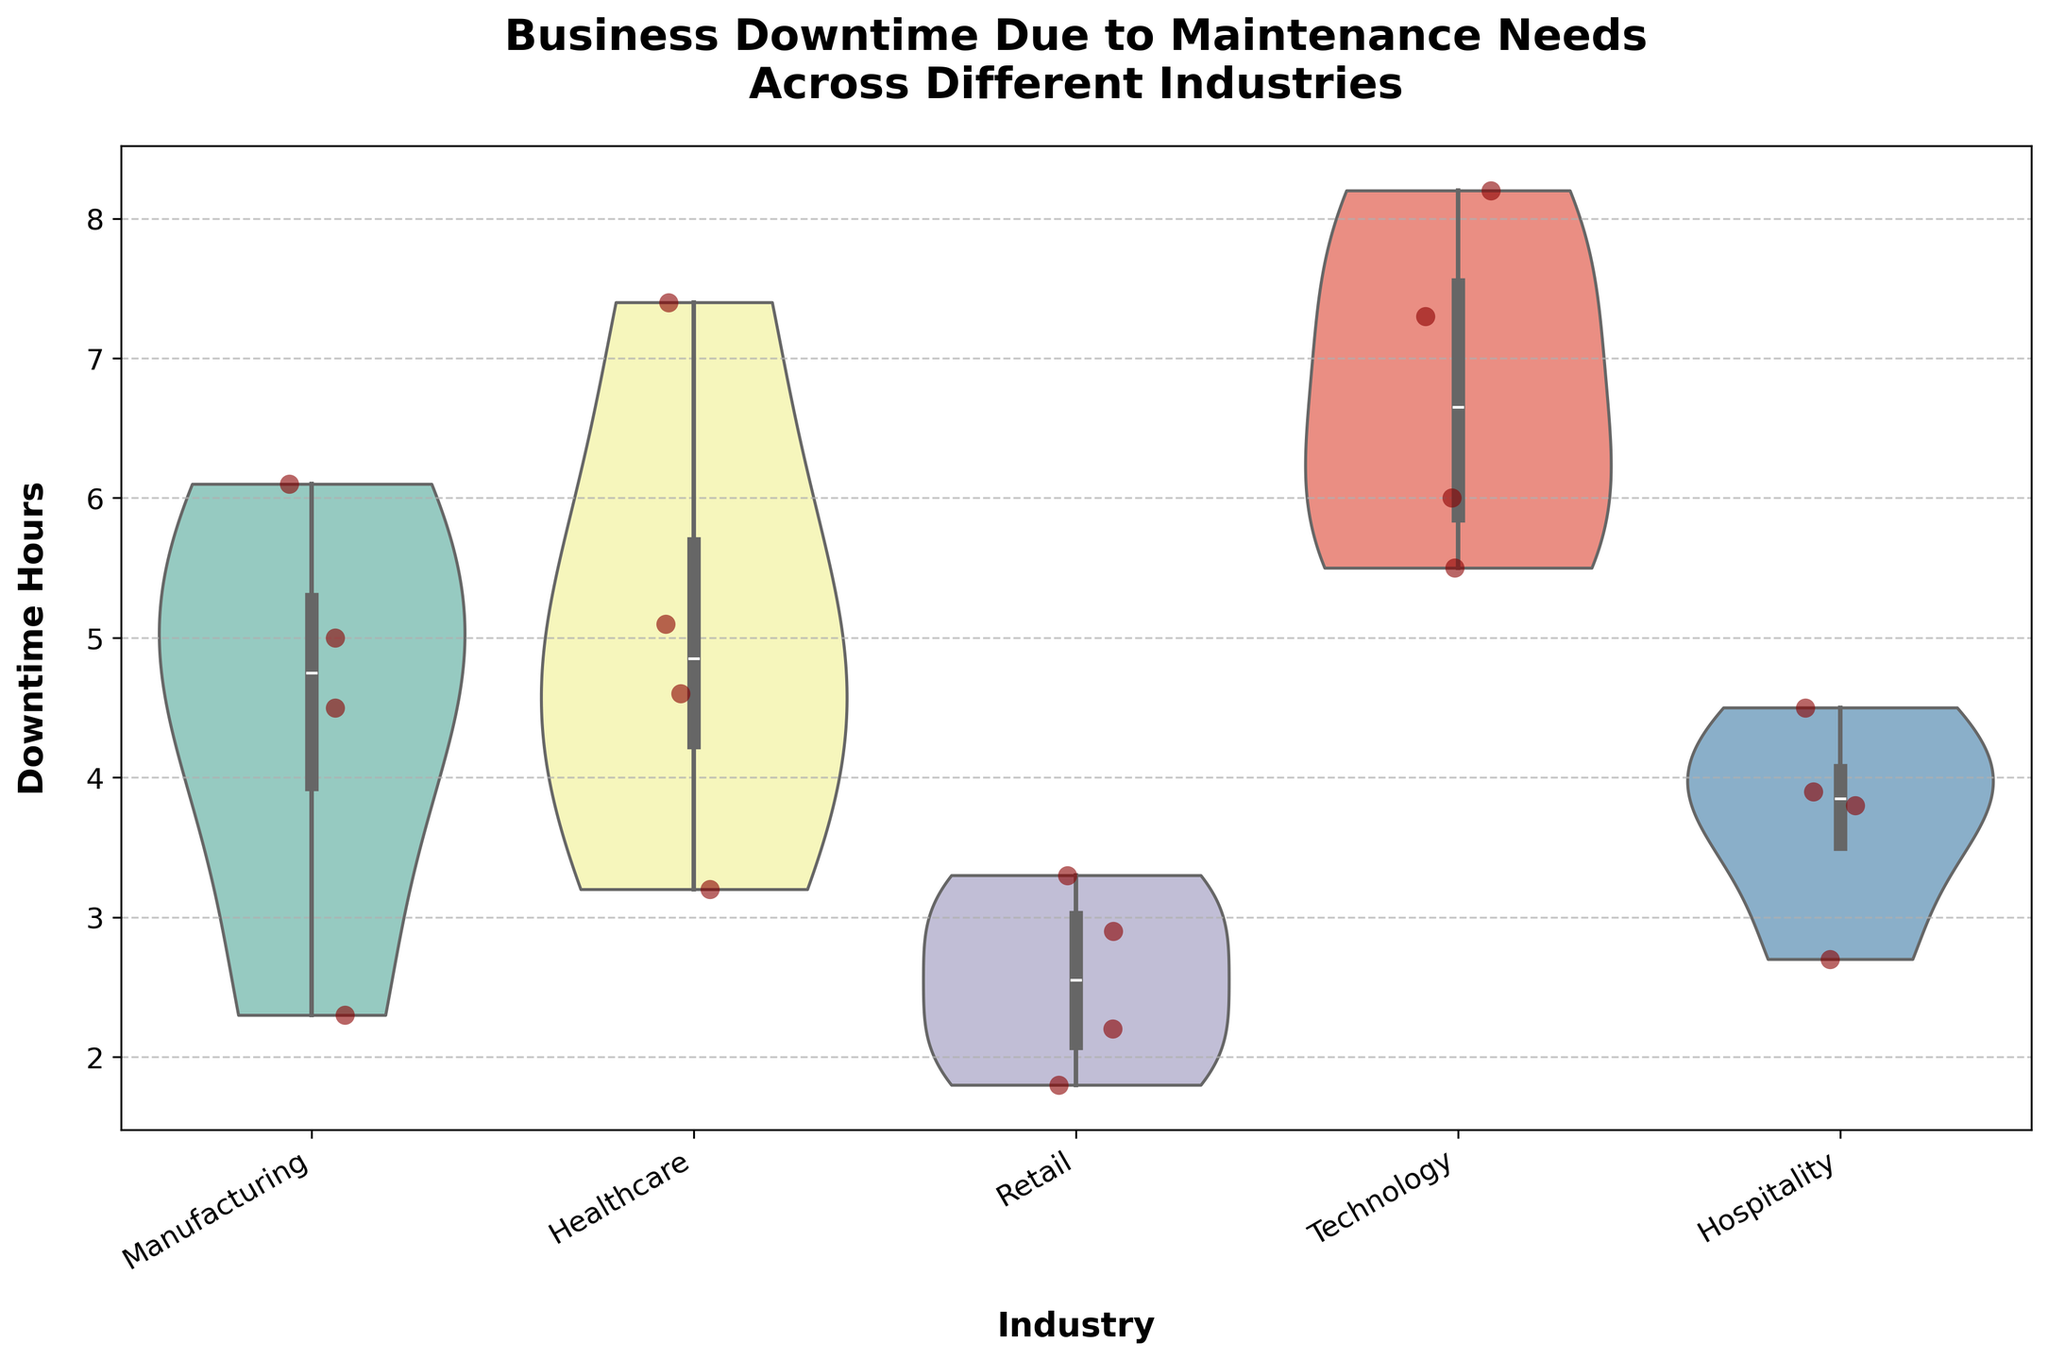How many industries are represented in the plot? Count the number of unique industry labels on the x-axis.
Answer: 5 Which industry has the highest median downtime hours? Identify the industry where the middle line (representing the median) within the violin plot is at the highest position on the y-axis.
Answer: Technology What is the range of downtime hours in the Healthcare industry? Look at the top and bottom edges of the violin plot for the Healthcare industry to find the maximum and minimum values.
Answer: 3.2 to 7.4 hours How does the distribution of downtime hours in Retail compare to Healthcare? Observe the shape and spread of the violin plots: Retail appears more concentrated towards lower values, while Healthcare has a wider spread towards higher values.
Answer: Retail is more concentrated at lower values Which company experienced the least amount of downtime hours, and in what industry does it operate? Identify the lowest individual jittered point and read off the corresponding industry label from the x-axis.
Answer: QuickMart in Retail What is the interquartile range (IQR) of downtime hours for Manufacturing? The IQR is the range between the first and third quartiles, which can be estimated by the width of the central box within the violin.
Answer: Approximately 2.3 to 6.1 hours Between Healthcare and Hospitality, which industry has a higher spread of downtime hours? Compare the width and length of the violins and the spread of jittered points for both industries.
Answer: Healthcare Are any industries showing signs of bimodal distribution in their downtime hours? Look for violin plots with two distinct peaks or humps.
Answer: No, all appear unimodal in distribution What can you infer about the variability of downtime in the Technology industry? Observing the wide and slightly elongated violin plot with multiple jittered points indicate high variability.
Answer: High variability Which industry shows the least and most consistent downtime? The violin plot for Retail is the shortest and least stretched, indicating the least variability. Conversely, the wide and tall plot for Technology shows high variability.
Answer: Retail (most consistent), Technology (least consistent) 